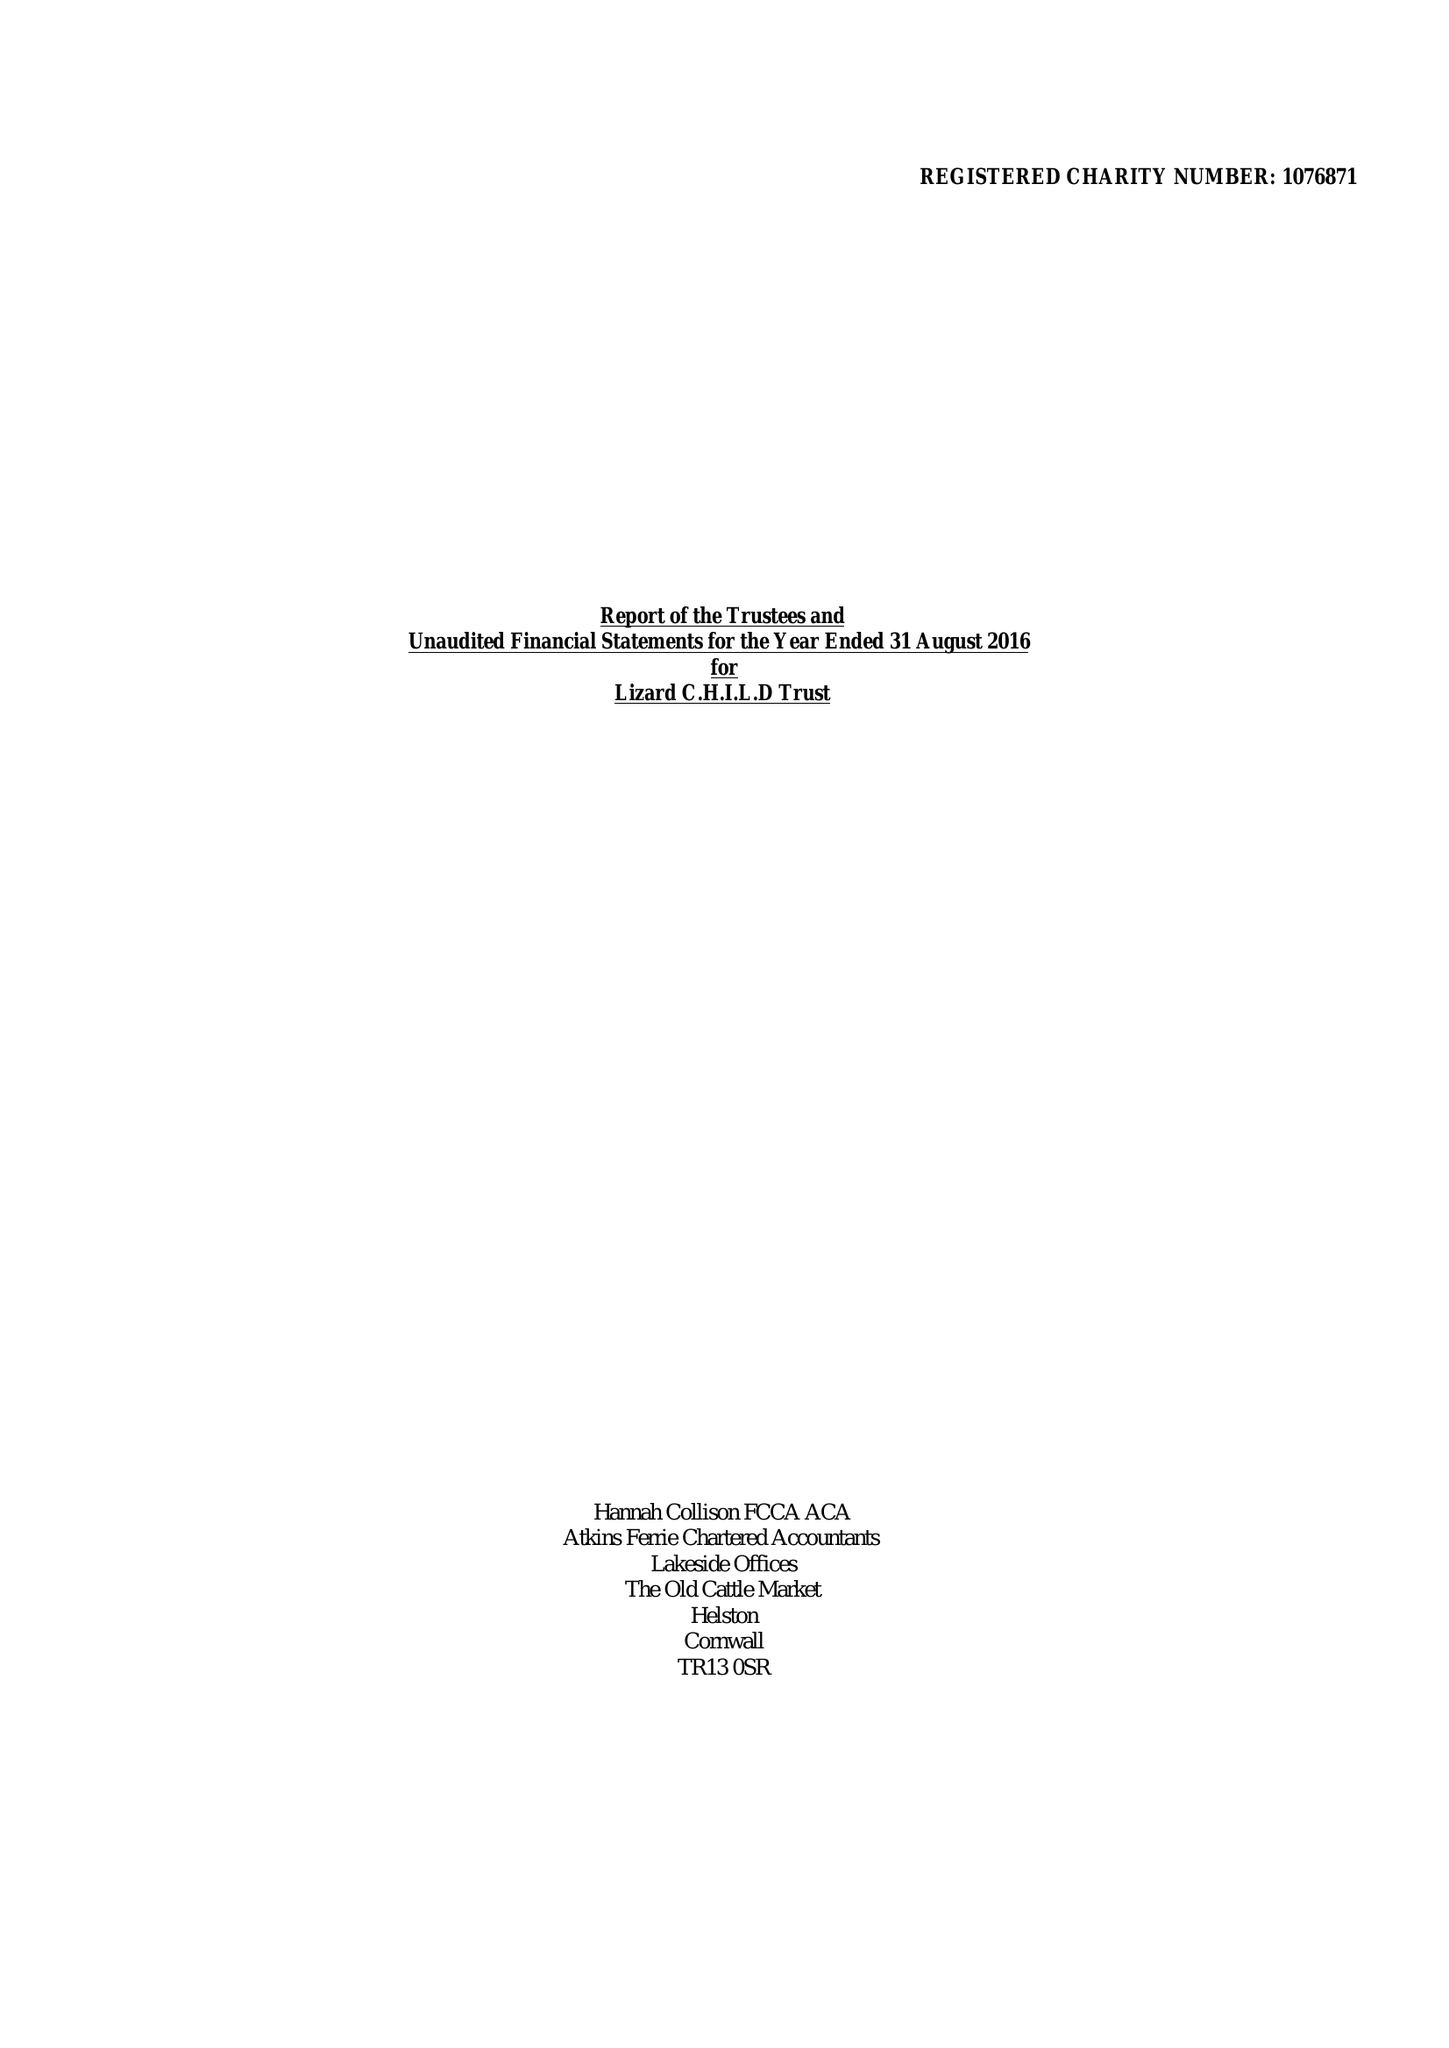What is the value for the charity_name?
Answer the question using a single word or phrase. Lizard C.H.I.L.D. Trust 